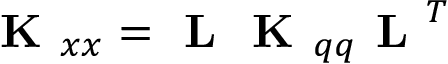<formula> <loc_0><loc_0><loc_500><loc_500>K _ { x x } = L K _ { q q } L ^ { T }</formula> 